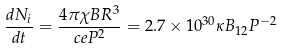<formula> <loc_0><loc_0><loc_500><loc_500>\frac { d N _ { i } } { d t } = \frac { 4 \pi \chi B R ^ { 3 } } { c e P ^ { 2 } } = 2 . 7 \times 1 0 ^ { 3 0 } \kappa B _ { 1 2 } P ^ { - 2 }</formula> 